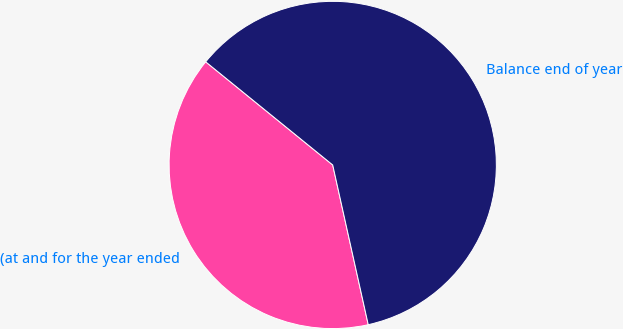Convert chart to OTSL. <chart><loc_0><loc_0><loc_500><loc_500><pie_chart><fcel>(at and for the year ended<fcel>Balance end of year<nl><fcel>39.34%<fcel>60.66%<nl></chart> 